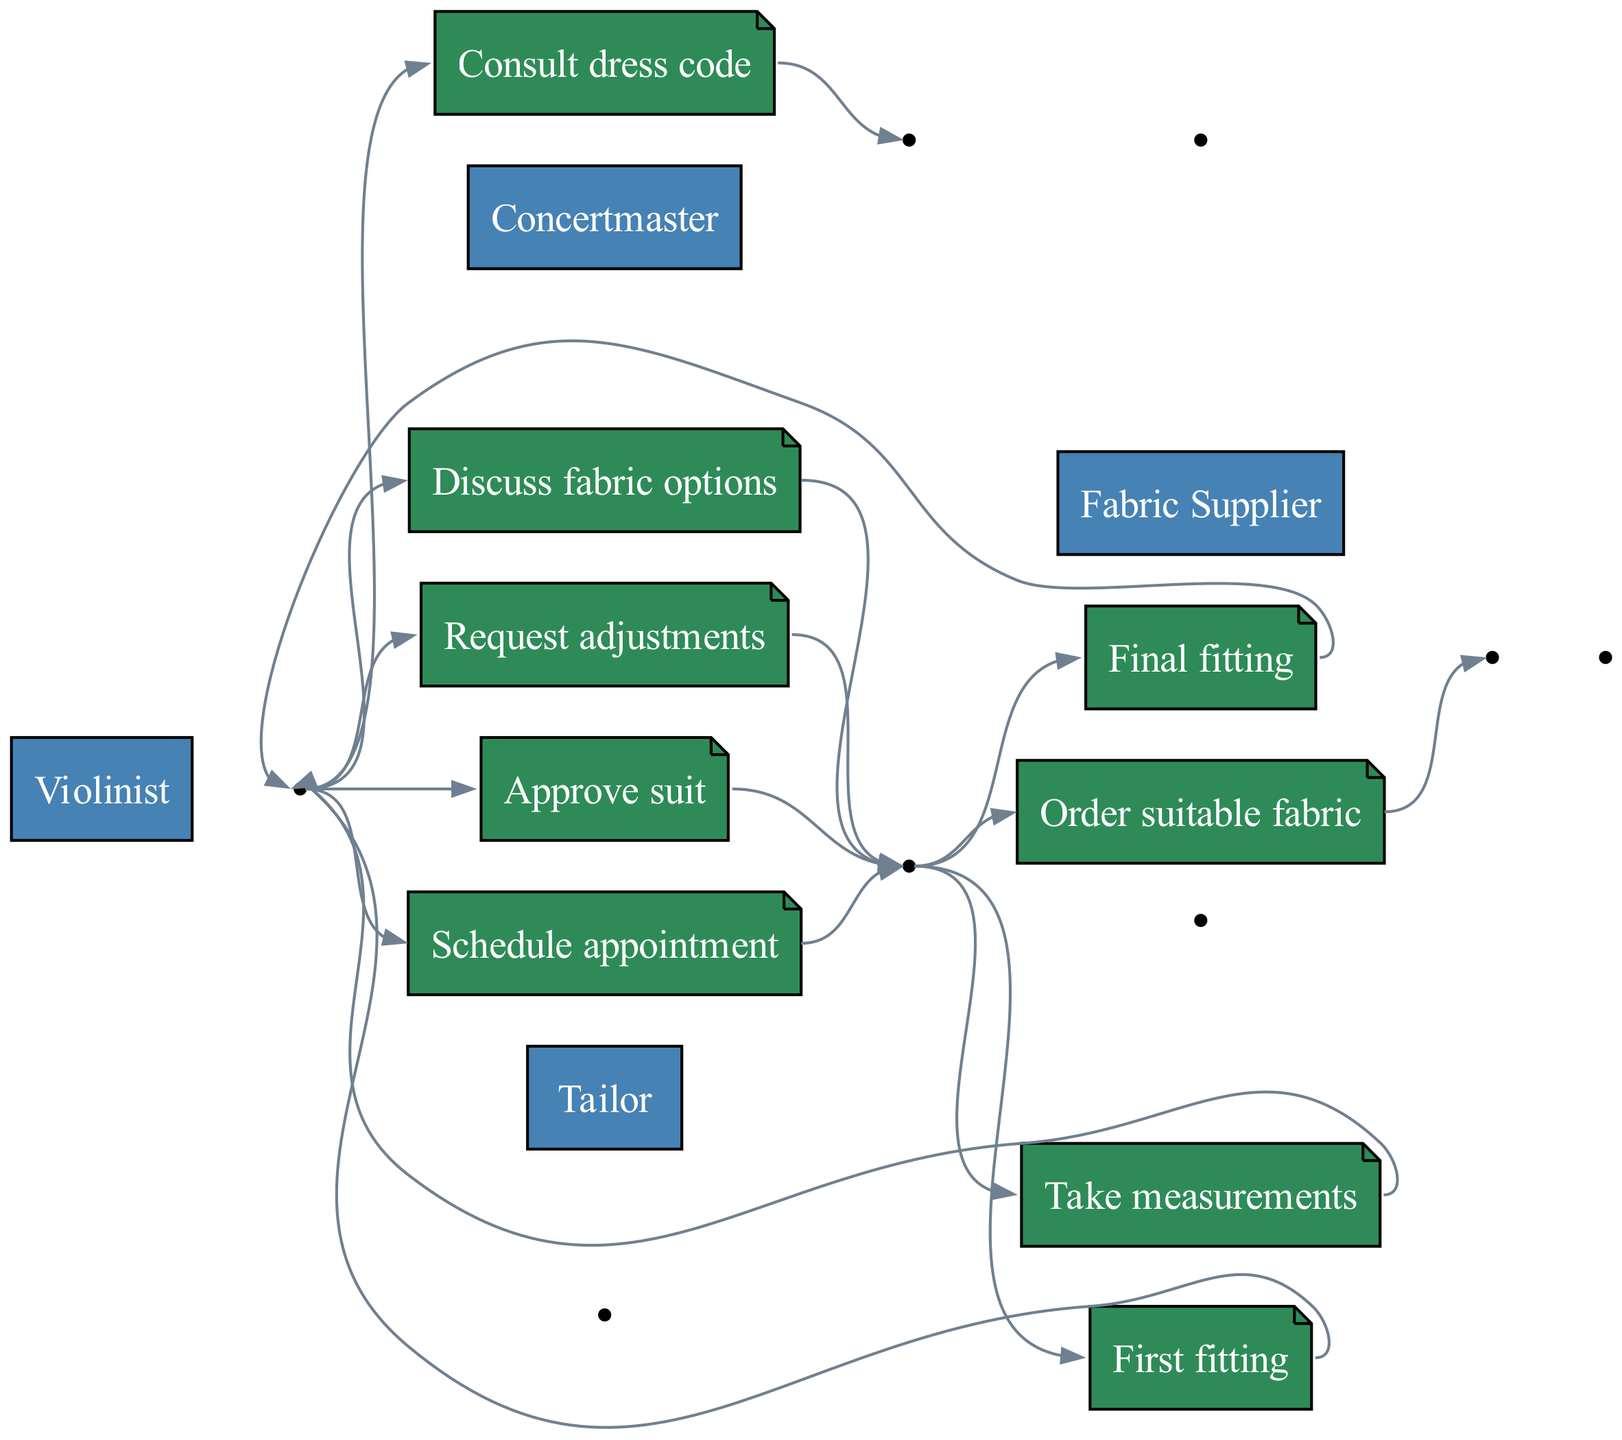What is the first action in the sequence? The first action listed in the sequence is between the Violinist and the Concertmaster, which is "Consult dress code."
Answer: Consult dress code How many actors are involved in this sequence diagram? The diagram specifies four distinct actors: Violinist, Tailor, Concertmaster, and Fabric Supplier.
Answer: Four Which two actors are involved in the action "First fitting"? The action "First fitting" involves the Tailor and the Violinist.
Answer: Tailor and Violinist What follows after the "Discuss fabric options" action? After the action "Discuss fabric options," the Tailor orders a suitable fabric from the Fabric Supplier.
Answer: Order suitable fabric What is the last action taken by the Violinist in the sequence? The last action taken by the Violinist is to "Approve suit."
Answer: Approve suit How many actions involve the Violinist? The Violinist is involved in five actions throughout the diagram.
Answer: Five Which actor orders fabric? The actor who places an order for fabric is the Tailor.
Answer: Tailor What is the relationship between the Tailor and Fabric Supplier? The relationship involves the Tailor ordering suitable fabric from the Fabric Supplier.
Answer: Orders fabric 